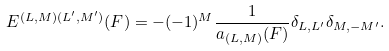Convert formula to latex. <formula><loc_0><loc_0><loc_500><loc_500>E ^ { ( L , M ) ( L ^ { \prime } , M ^ { \prime } ) } ( F ) = - ( - 1 ) ^ { M } \frac { 1 } { a _ { ( L , M ) } ( F ) } \delta _ { L , L ^ { \prime } } \delta _ { M , - M ^ { \prime } } .</formula> 